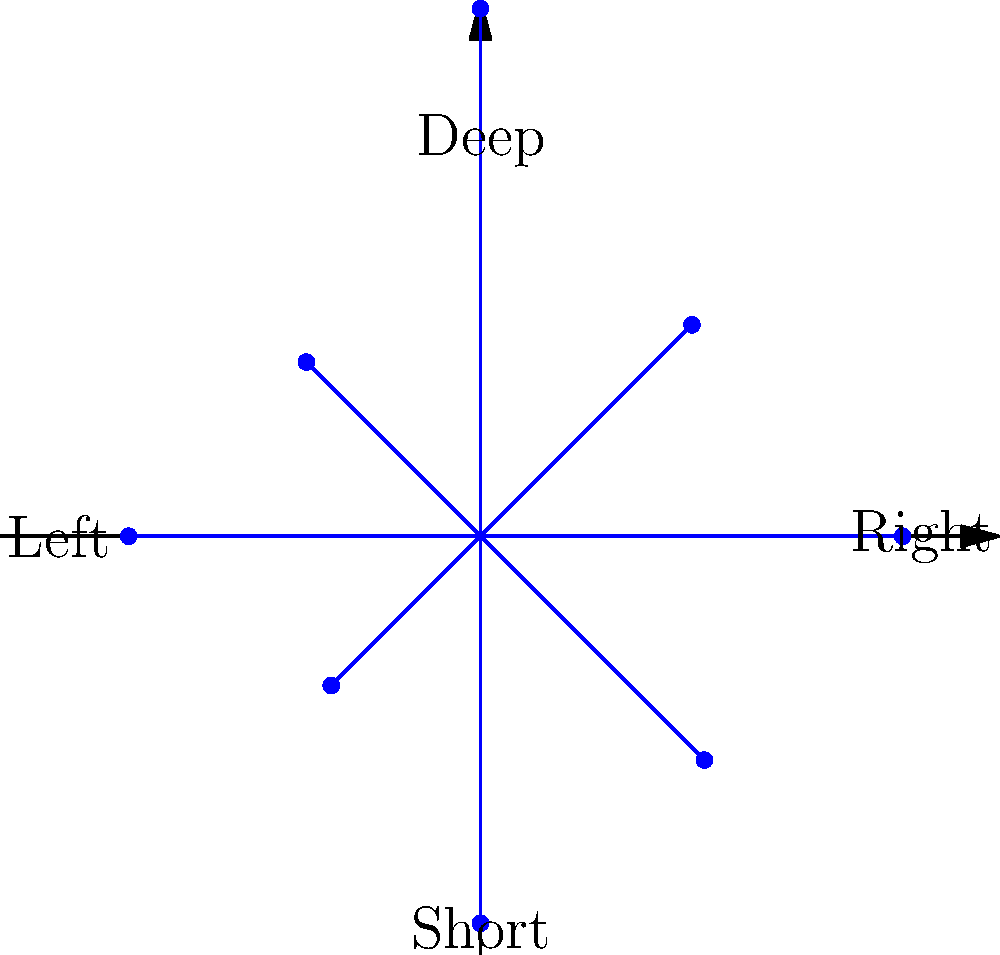In the polar rose diagram representing Le'Veon Bell's receiving yards distribution across different field positions, which direction shows the highest yardage accumulated? To determine the direction with the highest yardage accumulated, we need to analyze the polar rose diagram:

1. The diagram represents Bell's receiving yards in different field positions.
2. Each petal of the rose corresponds to a specific direction on the field.
3. The length of each petal represents the number of yards gained in that direction.
4. We need to identify the longest petal, which indicates the highest yardage.

Examining the diagram:
- The petal pointing towards the top (90° angle) is the longest.
- This direction corresponds to "Deep" passes on the field.
- The length of this petal is visibly longer than all others, indicating the highest yardage.

Therefore, Le'Veon Bell accumulated the most receiving yards on deep passes straight down the field.
Answer: Deep 